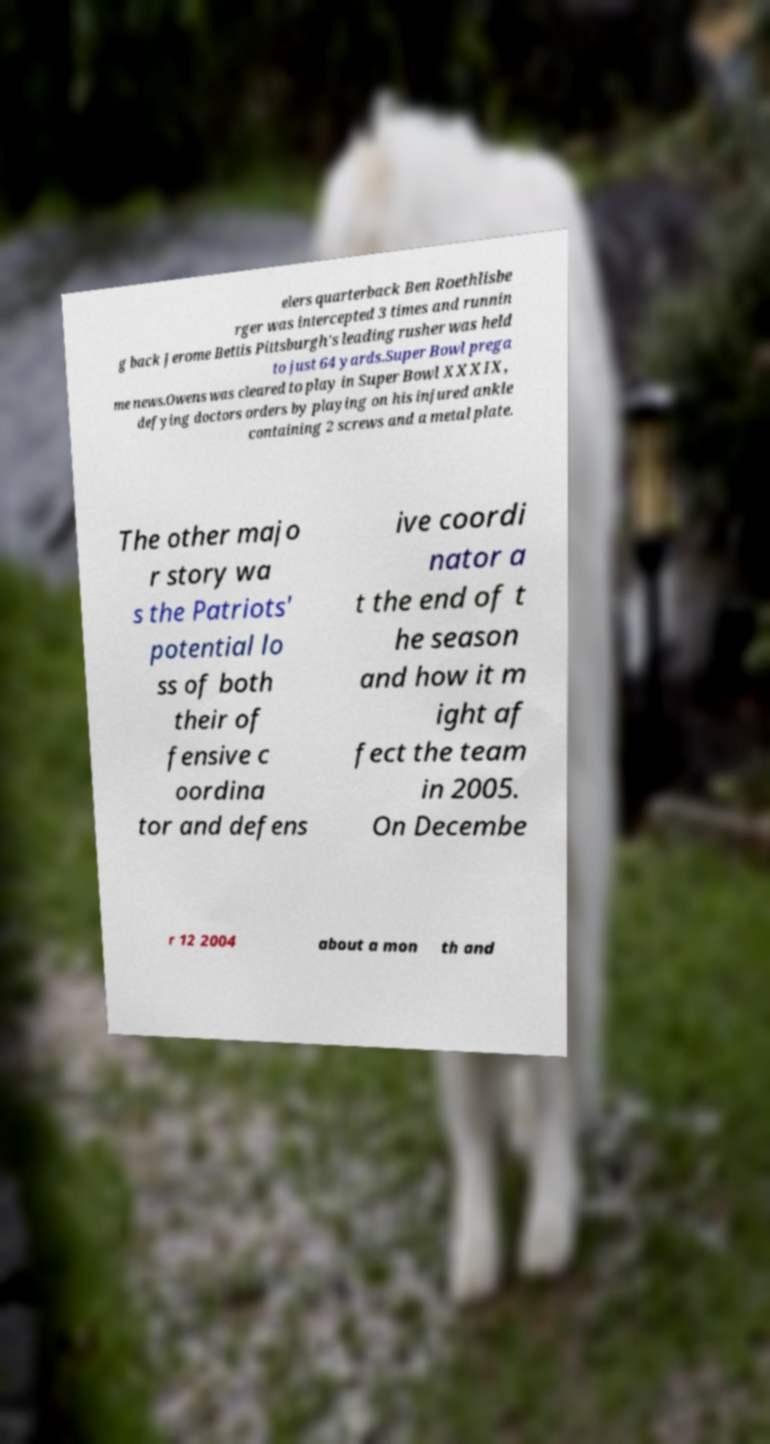Please identify and transcribe the text found in this image. elers quarterback Ben Roethlisbe rger was intercepted 3 times and runnin g back Jerome Bettis Pittsburgh's leading rusher was held to just 64 yards.Super Bowl prega me news.Owens was cleared to play in Super Bowl XXXIX, defying doctors orders by playing on his injured ankle containing 2 screws and a metal plate. The other majo r story wa s the Patriots' potential lo ss of both their of fensive c oordina tor and defens ive coordi nator a t the end of t he season and how it m ight af fect the team in 2005. On Decembe r 12 2004 about a mon th and 